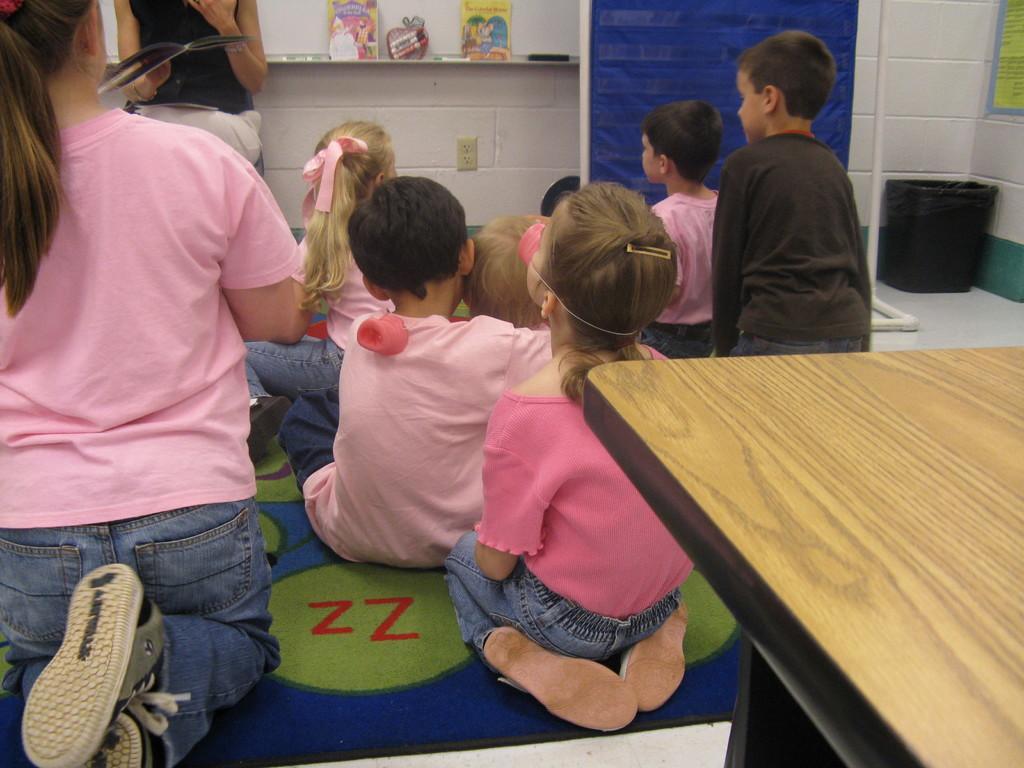Could you give a brief overview of what you see in this image? This children are sitting on a floor. Floor with carpet. This is a table. Near to the wall there are things. This woman is sitting on a chair holds a book. Far there is a bin. This is a blue color banner. 